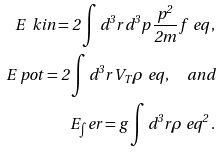Convert formula to latex. <formula><loc_0><loc_0><loc_500><loc_500>E _ { \ } k i n = 2 \int d ^ { 3 } r \, d ^ { 3 } p \, \frac { p ^ { 2 } } { 2 m } \, f _ { \ } e q \, , \\ E _ { \ } p o t = 2 \int d ^ { 3 } r \, V _ { T } \rho _ { \ } e q \, , \quad a n d \\ E _ { \int } e r = g \int d ^ { 3 } r \rho _ { \ } e q ^ { 2 } \, .</formula> 